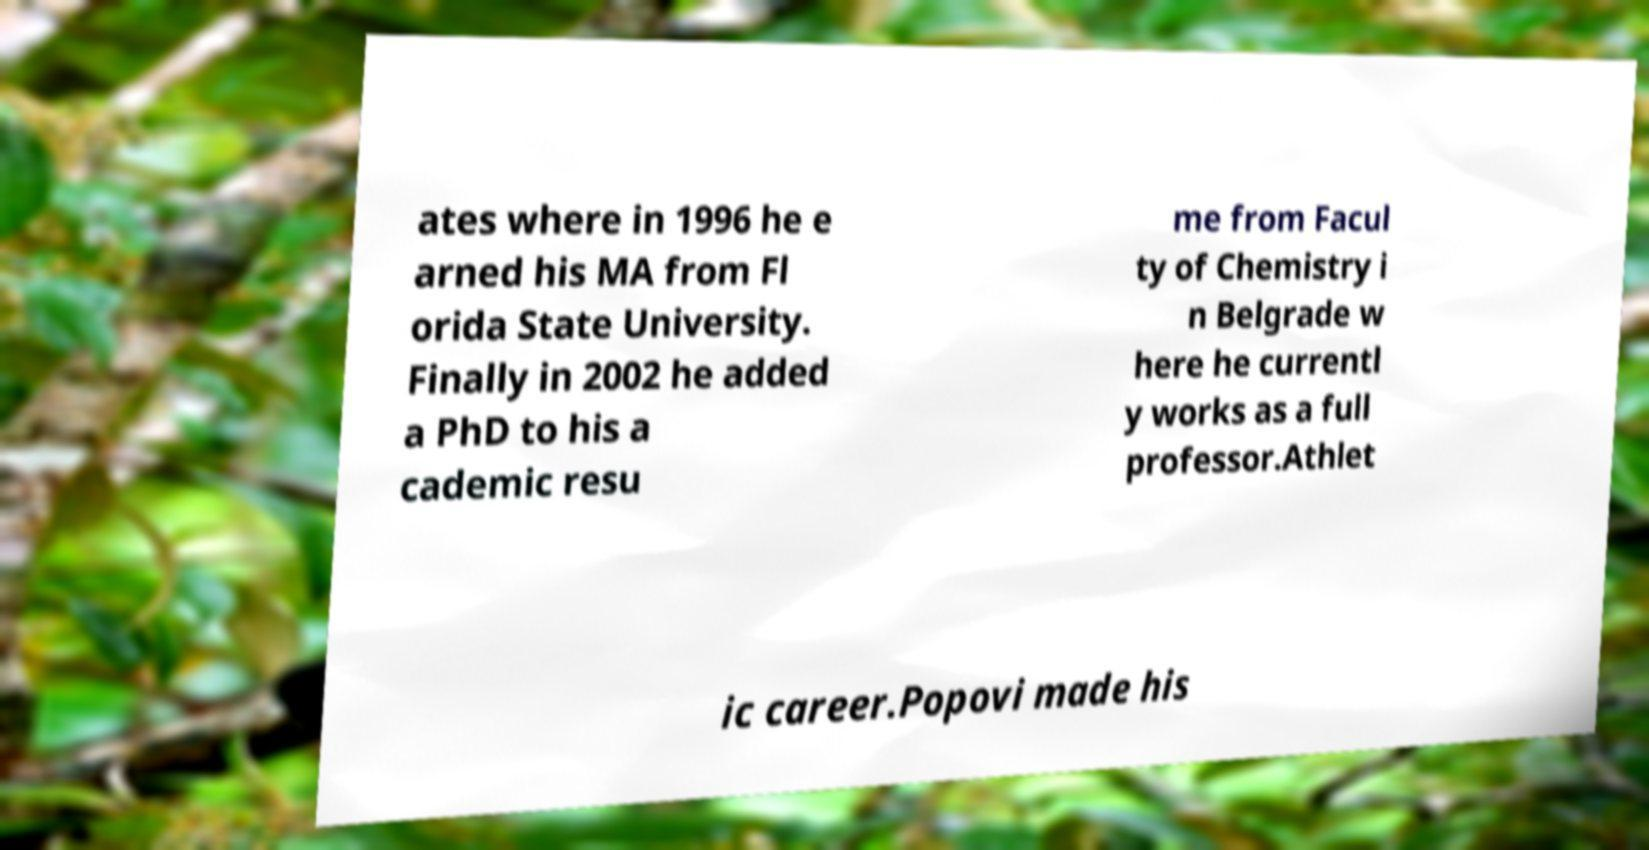There's text embedded in this image that I need extracted. Can you transcribe it verbatim? ates where in 1996 he e arned his MA from Fl orida State University. Finally in 2002 he added a PhD to his a cademic resu me from Facul ty of Chemistry i n Belgrade w here he currentl y works as a full professor.Athlet ic career.Popovi made his 